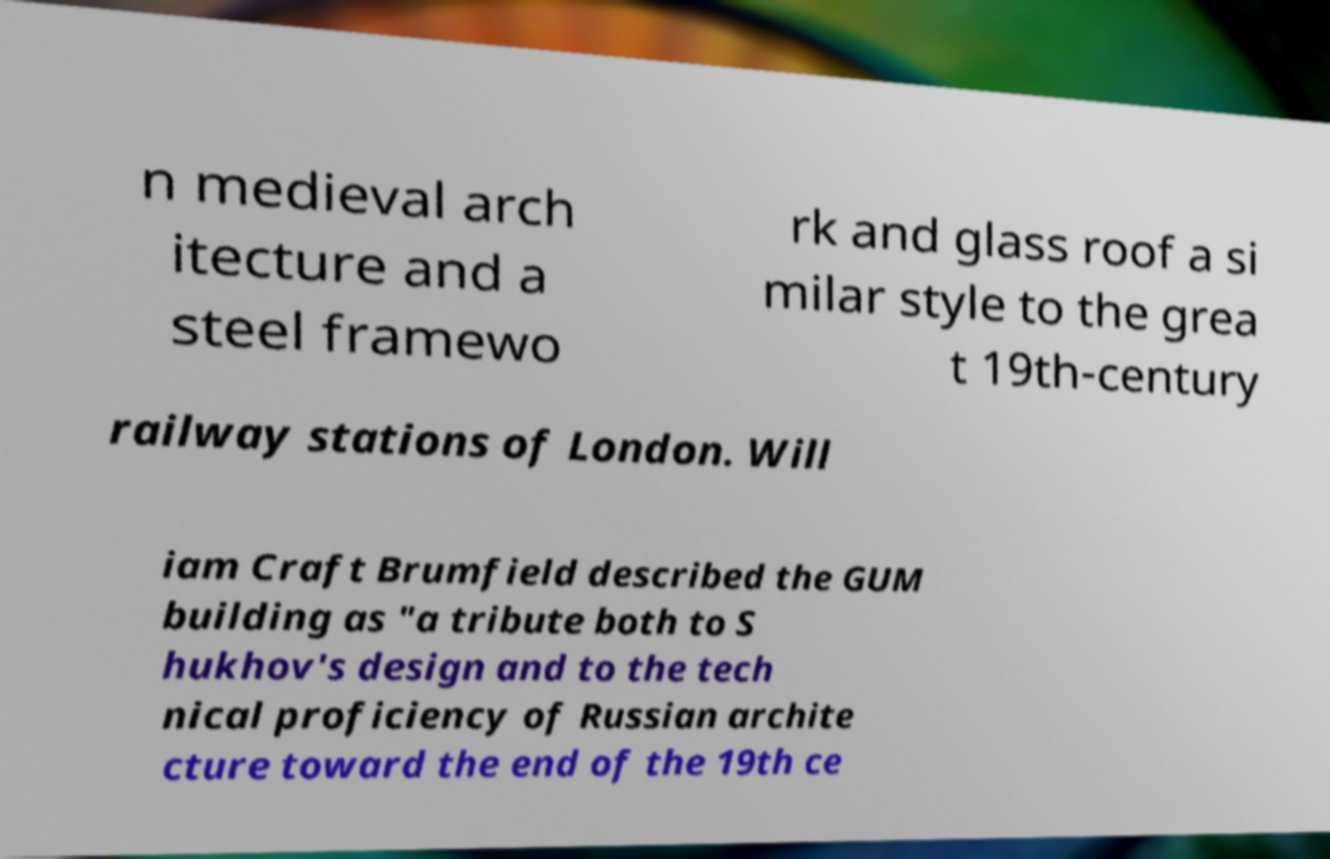Could you assist in decoding the text presented in this image and type it out clearly? n medieval arch itecture and a steel framewo rk and glass roof a si milar style to the grea t 19th-century railway stations of London. Will iam Craft Brumfield described the GUM building as "a tribute both to S hukhov's design and to the tech nical proficiency of Russian archite cture toward the end of the 19th ce 